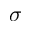Convert formula to latex. <formula><loc_0><loc_0><loc_500><loc_500>\sigma</formula> 